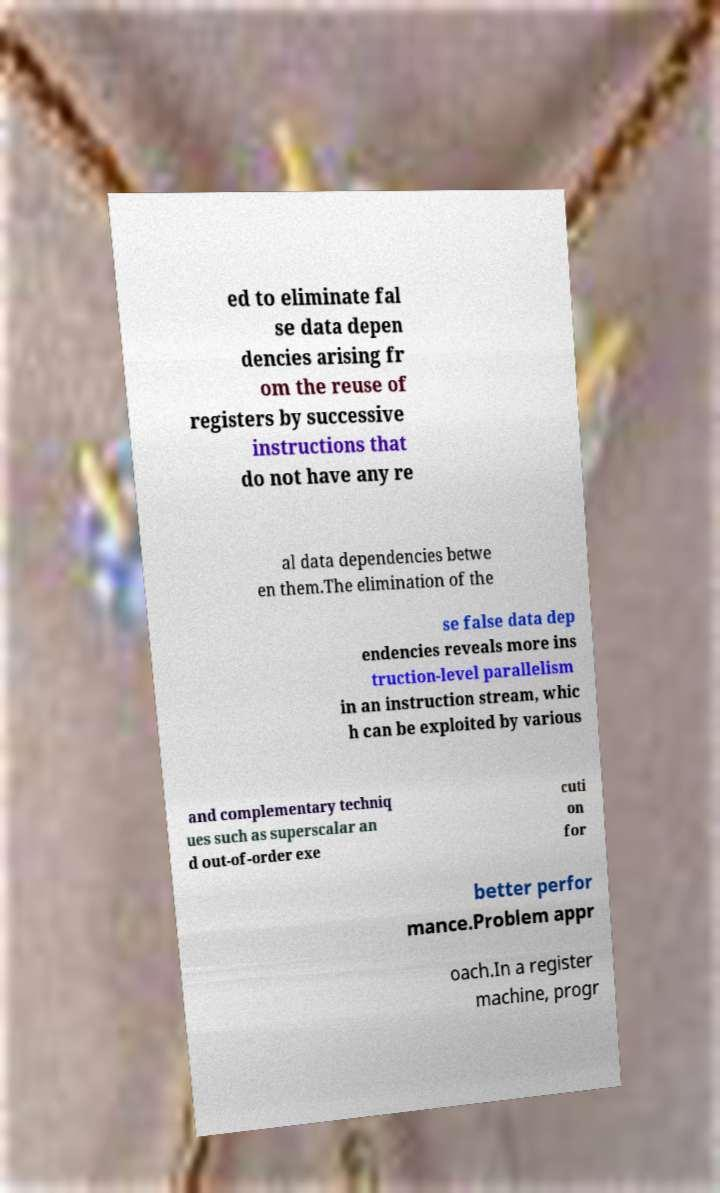There's text embedded in this image that I need extracted. Can you transcribe it verbatim? ed to eliminate fal se data depen dencies arising fr om the reuse of registers by successive instructions that do not have any re al data dependencies betwe en them.The elimination of the se false data dep endencies reveals more ins truction-level parallelism in an instruction stream, whic h can be exploited by various and complementary techniq ues such as superscalar an d out-of-order exe cuti on for better perfor mance.Problem appr oach.In a register machine, progr 